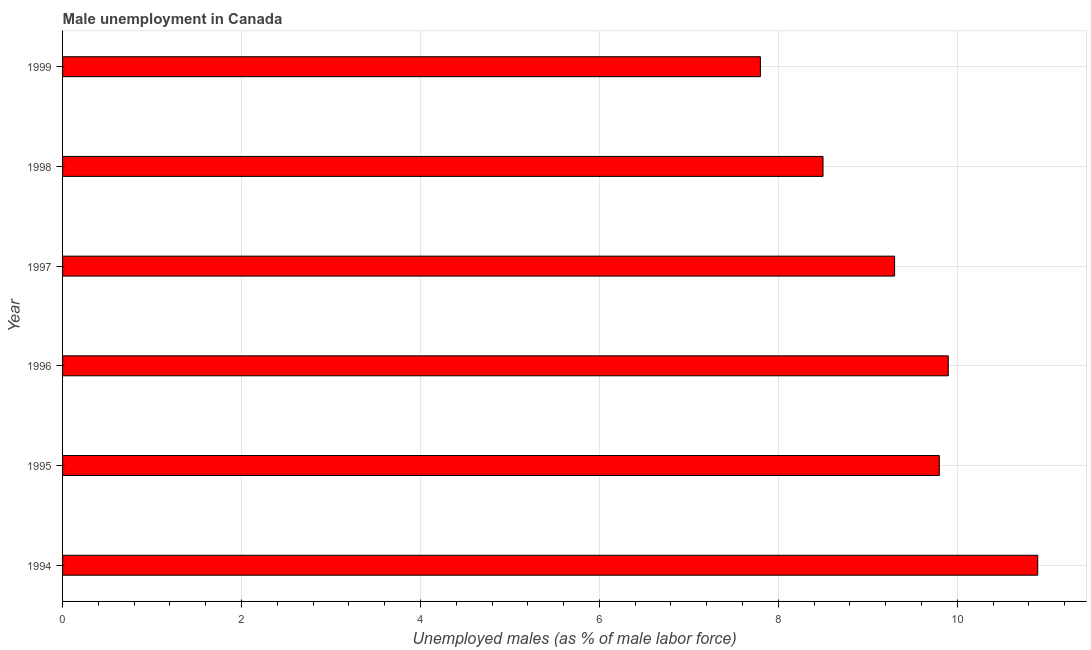Does the graph contain any zero values?
Offer a very short reply. No. Does the graph contain grids?
Provide a succinct answer. Yes. What is the title of the graph?
Ensure brevity in your answer.  Male unemployment in Canada. What is the label or title of the X-axis?
Offer a terse response. Unemployed males (as % of male labor force). What is the label or title of the Y-axis?
Offer a terse response. Year. What is the unemployed males population in 1998?
Your answer should be very brief. 8.5. Across all years, what is the maximum unemployed males population?
Provide a short and direct response. 10.9. Across all years, what is the minimum unemployed males population?
Provide a succinct answer. 7.8. In which year was the unemployed males population maximum?
Give a very brief answer. 1994. What is the sum of the unemployed males population?
Provide a succinct answer. 56.2. What is the difference between the unemployed males population in 1994 and 1999?
Provide a succinct answer. 3.1. What is the average unemployed males population per year?
Give a very brief answer. 9.37. What is the median unemployed males population?
Provide a short and direct response. 9.55. Do a majority of the years between 1994 and 1996 (inclusive) have unemployed males population greater than 2 %?
Offer a terse response. Yes. What is the ratio of the unemployed males population in 1994 to that in 1995?
Offer a terse response. 1.11. Is the unemployed males population in 1994 less than that in 1996?
Give a very brief answer. No. Is the difference between the unemployed males population in 1996 and 1998 greater than the difference between any two years?
Provide a short and direct response. No. In how many years, is the unemployed males population greater than the average unemployed males population taken over all years?
Provide a succinct answer. 3. How many bars are there?
Provide a short and direct response. 6. Are the values on the major ticks of X-axis written in scientific E-notation?
Provide a succinct answer. No. What is the Unemployed males (as % of male labor force) in 1994?
Make the answer very short. 10.9. What is the Unemployed males (as % of male labor force) in 1995?
Your response must be concise. 9.8. What is the Unemployed males (as % of male labor force) in 1996?
Offer a terse response. 9.9. What is the Unemployed males (as % of male labor force) of 1997?
Offer a terse response. 9.3. What is the Unemployed males (as % of male labor force) of 1998?
Keep it short and to the point. 8.5. What is the Unemployed males (as % of male labor force) of 1999?
Give a very brief answer. 7.8. What is the difference between the Unemployed males (as % of male labor force) in 1994 and 1995?
Offer a very short reply. 1.1. What is the difference between the Unemployed males (as % of male labor force) in 1994 and 1998?
Ensure brevity in your answer.  2.4. What is the difference between the Unemployed males (as % of male labor force) in 1995 and 1996?
Provide a short and direct response. -0.1. What is the difference between the Unemployed males (as % of male labor force) in 1995 and 1998?
Keep it short and to the point. 1.3. What is the difference between the Unemployed males (as % of male labor force) in 1995 and 1999?
Offer a very short reply. 2. What is the difference between the Unemployed males (as % of male labor force) in 1997 and 1998?
Your answer should be compact. 0.8. What is the difference between the Unemployed males (as % of male labor force) in 1998 and 1999?
Offer a terse response. 0.7. What is the ratio of the Unemployed males (as % of male labor force) in 1994 to that in 1995?
Provide a succinct answer. 1.11. What is the ratio of the Unemployed males (as % of male labor force) in 1994 to that in 1996?
Keep it short and to the point. 1.1. What is the ratio of the Unemployed males (as % of male labor force) in 1994 to that in 1997?
Offer a very short reply. 1.17. What is the ratio of the Unemployed males (as % of male labor force) in 1994 to that in 1998?
Provide a short and direct response. 1.28. What is the ratio of the Unemployed males (as % of male labor force) in 1994 to that in 1999?
Ensure brevity in your answer.  1.4. What is the ratio of the Unemployed males (as % of male labor force) in 1995 to that in 1997?
Your answer should be compact. 1.05. What is the ratio of the Unemployed males (as % of male labor force) in 1995 to that in 1998?
Make the answer very short. 1.15. What is the ratio of the Unemployed males (as % of male labor force) in 1995 to that in 1999?
Ensure brevity in your answer.  1.26. What is the ratio of the Unemployed males (as % of male labor force) in 1996 to that in 1997?
Provide a succinct answer. 1.06. What is the ratio of the Unemployed males (as % of male labor force) in 1996 to that in 1998?
Make the answer very short. 1.17. What is the ratio of the Unemployed males (as % of male labor force) in 1996 to that in 1999?
Your response must be concise. 1.27. What is the ratio of the Unemployed males (as % of male labor force) in 1997 to that in 1998?
Offer a terse response. 1.09. What is the ratio of the Unemployed males (as % of male labor force) in 1997 to that in 1999?
Provide a short and direct response. 1.19. What is the ratio of the Unemployed males (as % of male labor force) in 1998 to that in 1999?
Keep it short and to the point. 1.09. 